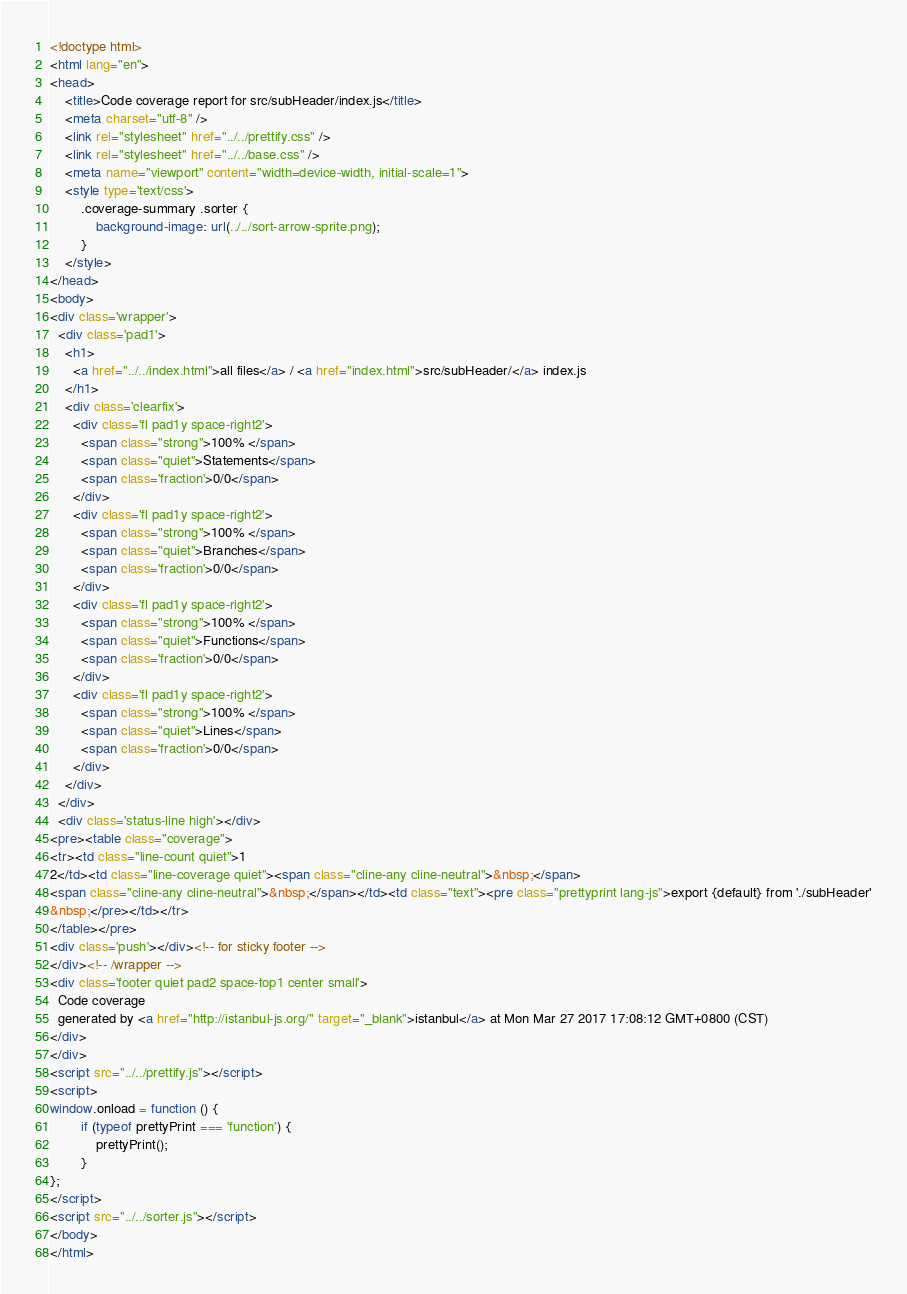Convert code to text. <code><loc_0><loc_0><loc_500><loc_500><_HTML_><!doctype html>
<html lang="en">
<head>
    <title>Code coverage report for src/subHeader/index.js</title>
    <meta charset="utf-8" />
    <link rel="stylesheet" href="../../prettify.css" />
    <link rel="stylesheet" href="../../base.css" />
    <meta name="viewport" content="width=device-width, initial-scale=1">
    <style type='text/css'>
        .coverage-summary .sorter {
            background-image: url(../../sort-arrow-sprite.png);
        }
    </style>
</head>
<body>
<div class='wrapper'>
  <div class='pad1'>
    <h1>
      <a href="../../index.html">all files</a> / <a href="index.html">src/subHeader/</a> index.js
    </h1>
    <div class='clearfix'>
      <div class='fl pad1y space-right2'>
        <span class="strong">100% </span>
        <span class="quiet">Statements</span>
        <span class='fraction'>0/0</span>
      </div>
      <div class='fl pad1y space-right2'>
        <span class="strong">100% </span>
        <span class="quiet">Branches</span>
        <span class='fraction'>0/0</span>
      </div>
      <div class='fl pad1y space-right2'>
        <span class="strong">100% </span>
        <span class="quiet">Functions</span>
        <span class='fraction'>0/0</span>
      </div>
      <div class='fl pad1y space-right2'>
        <span class="strong">100% </span>
        <span class="quiet">Lines</span>
        <span class='fraction'>0/0</span>
      </div>
    </div>
  </div>
  <div class='status-line high'></div>
<pre><table class="coverage">
<tr><td class="line-count quiet">1
2</td><td class="line-coverage quiet"><span class="cline-any cline-neutral">&nbsp;</span>
<span class="cline-any cline-neutral">&nbsp;</span></td><td class="text"><pre class="prettyprint lang-js">export {default} from './subHeader'
&nbsp;</pre></td></tr>
</table></pre>
<div class='push'></div><!-- for sticky footer -->
</div><!-- /wrapper -->
<div class='footer quiet pad2 space-top1 center small'>
  Code coverage
  generated by <a href="http://istanbul-js.org/" target="_blank">istanbul</a> at Mon Mar 27 2017 17:08:12 GMT+0800 (CST)
</div>
</div>
<script src="../../prettify.js"></script>
<script>
window.onload = function () {
        if (typeof prettyPrint === 'function') {
            prettyPrint();
        }
};
</script>
<script src="../../sorter.js"></script>
</body>
</html>
</code> 